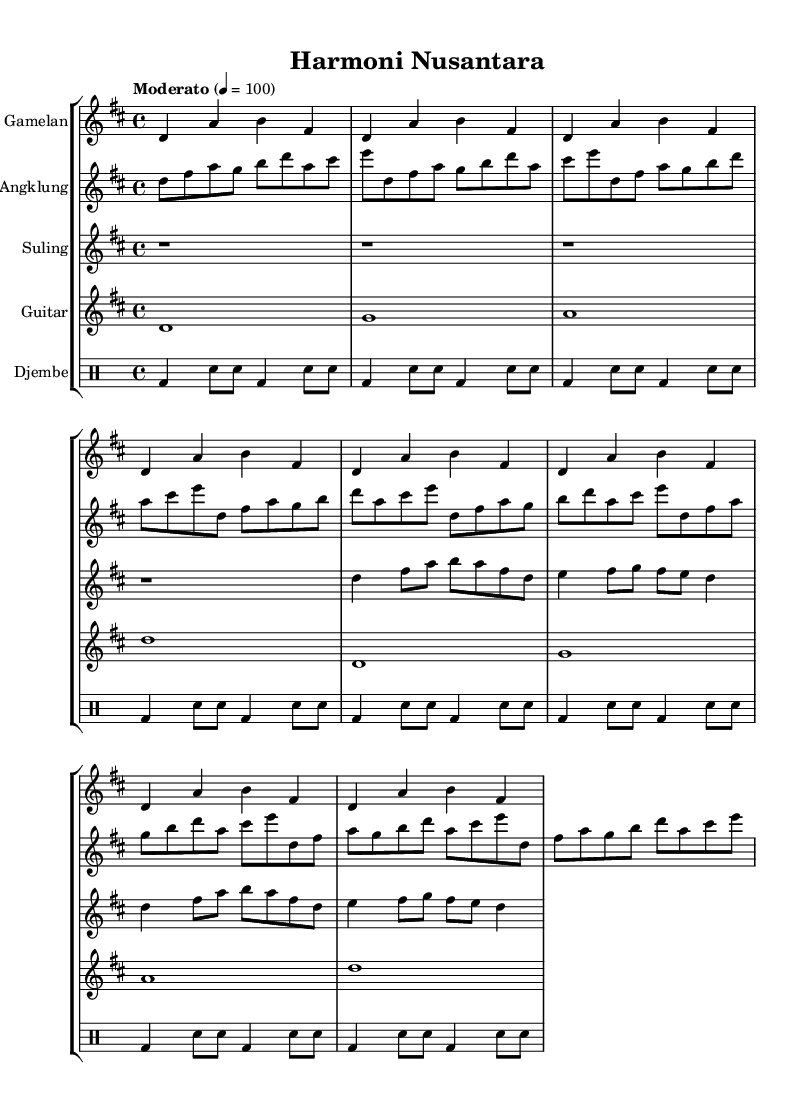What is the key signature of this music? The key signature is D major, which has two sharps (F# and C#). This can be identified by looking at the key signature marking at the beginning of the sheet music, where the note positions indicate the sharps.
Answer: D major What is the time signature of this music? The time signature is 4/4, represented at the beginning of the sheet music by the “4/4” marking. This indicates that there are four beats in each measure and a quarter note gets one beat.
Answer: 4/4 What is the tempo marking for this composition? The tempo marking is "Moderato," which suggests a moderate speed for the piece. This is indicated by the tempo marking provided in the score above the staff.
Answer: Moderato How many measures does the gamelan part repeat? The gamelan part repeats 8 times, as shown by the repeat sign and the corresponding notation under that part. This indicates that the section should be played according to the given measures before repeating.
Answer: 8 Which instruments are featured in this score? The featured instruments are Gamelan, Angklung, Suling, Guitar, and Djembe. Each instrument has a designated staff in the score, clearly labeled with its name above the notation.
Answer: Gamelan, Angklung, Suling, Guitar, Djembe What type of feel does the djembe provide to the composition? The djembe provides a rhythmic foundation; the drum patterns played create a strong, percussive element supporting the melodic lines of the other instruments. This is deduced from the drum notation and its placement within the score which emphasizes rhythm.
Answer: Rhythmic foundation How does the usage of Indonesian instruments contribute to cultural diversity in this piece? The inclusion of Indonesian instruments such as Gamelan and Angklung alongside international instruments like Guitar showcases a blend of musical traditions, enhancing cultural diversity. This is observed in the variety of instruments represented that reflect different cultural backgrounds and styles.
Answer: Enhances cultural diversity 